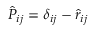Convert formula to latex. <formula><loc_0><loc_0><loc_500><loc_500>\hat { P } _ { i j } = \delta _ { i j } - \hat { r } _ { i j }</formula> 